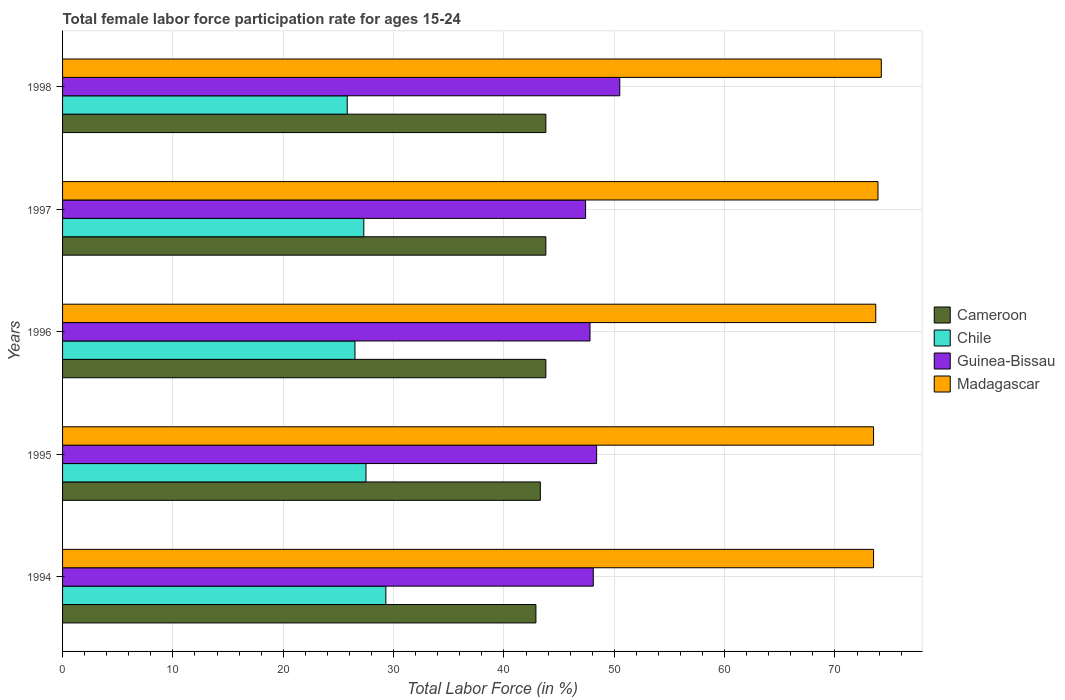How many different coloured bars are there?
Your response must be concise. 4. How many groups of bars are there?
Offer a terse response. 5. In how many cases, is the number of bars for a given year not equal to the number of legend labels?
Your answer should be compact. 0. What is the female labor force participation rate in Madagascar in 1998?
Your answer should be compact. 74.2. Across all years, what is the maximum female labor force participation rate in Guinea-Bissau?
Your answer should be compact. 50.5. Across all years, what is the minimum female labor force participation rate in Cameroon?
Your answer should be compact. 42.9. In which year was the female labor force participation rate in Chile maximum?
Give a very brief answer. 1994. What is the total female labor force participation rate in Chile in the graph?
Keep it short and to the point. 136.4. What is the difference between the female labor force participation rate in Madagascar in 1995 and that in 1997?
Make the answer very short. -0.4. What is the difference between the female labor force participation rate in Chile in 1995 and the female labor force participation rate in Guinea-Bissau in 1997?
Provide a succinct answer. -19.9. What is the average female labor force participation rate in Madagascar per year?
Give a very brief answer. 73.76. In how many years, is the female labor force participation rate in Guinea-Bissau greater than 68 %?
Your answer should be compact. 0. What is the ratio of the female labor force participation rate in Madagascar in 1996 to that in 1997?
Your answer should be very brief. 1. Is the female labor force participation rate in Guinea-Bissau in 1996 less than that in 1998?
Keep it short and to the point. Yes. What is the difference between the highest and the second highest female labor force participation rate in Madagascar?
Give a very brief answer. 0.3. What is the difference between the highest and the lowest female labor force participation rate in Guinea-Bissau?
Give a very brief answer. 3.1. Is the sum of the female labor force participation rate in Guinea-Bissau in 1994 and 1998 greater than the maximum female labor force participation rate in Madagascar across all years?
Keep it short and to the point. Yes. Is it the case that in every year, the sum of the female labor force participation rate in Madagascar and female labor force participation rate in Guinea-Bissau is greater than the female labor force participation rate in Chile?
Your response must be concise. Yes. How many years are there in the graph?
Offer a terse response. 5. What is the difference between two consecutive major ticks on the X-axis?
Your response must be concise. 10. Where does the legend appear in the graph?
Make the answer very short. Center right. How many legend labels are there?
Your answer should be compact. 4. What is the title of the graph?
Give a very brief answer. Total female labor force participation rate for ages 15-24. Does "New Zealand" appear as one of the legend labels in the graph?
Your answer should be compact. No. What is the Total Labor Force (in %) of Cameroon in 1994?
Provide a succinct answer. 42.9. What is the Total Labor Force (in %) of Chile in 1994?
Your response must be concise. 29.3. What is the Total Labor Force (in %) of Guinea-Bissau in 1994?
Your answer should be very brief. 48.1. What is the Total Labor Force (in %) of Madagascar in 1994?
Your answer should be very brief. 73.5. What is the Total Labor Force (in %) in Cameroon in 1995?
Your answer should be compact. 43.3. What is the Total Labor Force (in %) of Chile in 1995?
Offer a terse response. 27.5. What is the Total Labor Force (in %) in Guinea-Bissau in 1995?
Provide a short and direct response. 48.4. What is the Total Labor Force (in %) of Madagascar in 1995?
Make the answer very short. 73.5. What is the Total Labor Force (in %) in Cameroon in 1996?
Provide a succinct answer. 43.8. What is the Total Labor Force (in %) in Chile in 1996?
Provide a short and direct response. 26.5. What is the Total Labor Force (in %) in Guinea-Bissau in 1996?
Offer a very short reply. 47.8. What is the Total Labor Force (in %) in Madagascar in 1996?
Make the answer very short. 73.7. What is the Total Labor Force (in %) of Cameroon in 1997?
Ensure brevity in your answer.  43.8. What is the Total Labor Force (in %) in Chile in 1997?
Provide a succinct answer. 27.3. What is the Total Labor Force (in %) of Guinea-Bissau in 1997?
Your response must be concise. 47.4. What is the Total Labor Force (in %) of Madagascar in 1997?
Make the answer very short. 73.9. What is the Total Labor Force (in %) in Cameroon in 1998?
Your answer should be compact. 43.8. What is the Total Labor Force (in %) in Chile in 1998?
Ensure brevity in your answer.  25.8. What is the Total Labor Force (in %) of Guinea-Bissau in 1998?
Keep it short and to the point. 50.5. What is the Total Labor Force (in %) of Madagascar in 1998?
Your answer should be very brief. 74.2. Across all years, what is the maximum Total Labor Force (in %) of Cameroon?
Offer a very short reply. 43.8. Across all years, what is the maximum Total Labor Force (in %) of Chile?
Your answer should be compact. 29.3. Across all years, what is the maximum Total Labor Force (in %) of Guinea-Bissau?
Offer a very short reply. 50.5. Across all years, what is the maximum Total Labor Force (in %) of Madagascar?
Your answer should be compact. 74.2. Across all years, what is the minimum Total Labor Force (in %) in Cameroon?
Your answer should be compact. 42.9. Across all years, what is the minimum Total Labor Force (in %) of Chile?
Offer a terse response. 25.8. Across all years, what is the minimum Total Labor Force (in %) in Guinea-Bissau?
Provide a short and direct response. 47.4. Across all years, what is the minimum Total Labor Force (in %) of Madagascar?
Your answer should be very brief. 73.5. What is the total Total Labor Force (in %) of Cameroon in the graph?
Offer a very short reply. 217.6. What is the total Total Labor Force (in %) of Chile in the graph?
Offer a terse response. 136.4. What is the total Total Labor Force (in %) in Guinea-Bissau in the graph?
Your response must be concise. 242.2. What is the total Total Labor Force (in %) of Madagascar in the graph?
Keep it short and to the point. 368.8. What is the difference between the Total Labor Force (in %) in Cameroon in 1994 and that in 1995?
Make the answer very short. -0.4. What is the difference between the Total Labor Force (in %) in Chile in 1994 and that in 1995?
Offer a very short reply. 1.8. What is the difference between the Total Labor Force (in %) of Madagascar in 1994 and that in 1996?
Your answer should be very brief. -0.2. What is the difference between the Total Labor Force (in %) of Cameroon in 1994 and that in 1997?
Provide a short and direct response. -0.9. What is the difference between the Total Labor Force (in %) of Chile in 1994 and that in 1997?
Offer a very short reply. 2. What is the difference between the Total Labor Force (in %) in Guinea-Bissau in 1994 and that in 1997?
Your answer should be very brief. 0.7. What is the difference between the Total Labor Force (in %) in Cameroon in 1994 and that in 1998?
Offer a very short reply. -0.9. What is the difference between the Total Labor Force (in %) in Chile in 1994 and that in 1998?
Offer a very short reply. 3.5. What is the difference between the Total Labor Force (in %) in Guinea-Bissau in 1994 and that in 1998?
Your answer should be very brief. -2.4. What is the difference between the Total Labor Force (in %) of Chile in 1995 and that in 1996?
Your response must be concise. 1. What is the difference between the Total Labor Force (in %) in Madagascar in 1995 and that in 1996?
Your answer should be compact. -0.2. What is the difference between the Total Labor Force (in %) in Cameroon in 1995 and that in 1997?
Provide a succinct answer. -0.5. What is the difference between the Total Labor Force (in %) of Chile in 1995 and that in 1997?
Provide a succinct answer. 0.2. What is the difference between the Total Labor Force (in %) in Madagascar in 1995 and that in 1997?
Keep it short and to the point. -0.4. What is the difference between the Total Labor Force (in %) of Guinea-Bissau in 1995 and that in 1998?
Your response must be concise. -2.1. What is the difference between the Total Labor Force (in %) of Cameroon in 1996 and that in 1997?
Offer a terse response. 0. What is the difference between the Total Labor Force (in %) of Guinea-Bissau in 1996 and that in 1997?
Offer a terse response. 0.4. What is the difference between the Total Labor Force (in %) in Madagascar in 1996 and that in 1997?
Offer a terse response. -0.2. What is the difference between the Total Labor Force (in %) of Madagascar in 1997 and that in 1998?
Offer a terse response. -0.3. What is the difference between the Total Labor Force (in %) of Cameroon in 1994 and the Total Labor Force (in %) of Madagascar in 1995?
Give a very brief answer. -30.6. What is the difference between the Total Labor Force (in %) in Chile in 1994 and the Total Labor Force (in %) in Guinea-Bissau in 1995?
Give a very brief answer. -19.1. What is the difference between the Total Labor Force (in %) in Chile in 1994 and the Total Labor Force (in %) in Madagascar in 1995?
Your answer should be compact. -44.2. What is the difference between the Total Labor Force (in %) of Guinea-Bissau in 1994 and the Total Labor Force (in %) of Madagascar in 1995?
Offer a very short reply. -25.4. What is the difference between the Total Labor Force (in %) of Cameroon in 1994 and the Total Labor Force (in %) of Chile in 1996?
Make the answer very short. 16.4. What is the difference between the Total Labor Force (in %) in Cameroon in 1994 and the Total Labor Force (in %) in Guinea-Bissau in 1996?
Your response must be concise. -4.9. What is the difference between the Total Labor Force (in %) of Cameroon in 1994 and the Total Labor Force (in %) of Madagascar in 1996?
Offer a terse response. -30.8. What is the difference between the Total Labor Force (in %) in Chile in 1994 and the Total Labor Force (in %) in Guinea-Bissau in 1996?
Make the answer very short. -18.5. What is the difference between the Total Labor Force (in %) in Chile in 1994 and the Total Labor Force (in %) in Madagascar in 1996?
Provide a short and direct response. -44.4. What is the difference between the Total Labor Force (in %) in Guinea-Bissau in 1994 and the Total Labor Force (in %) in Madagascar in 1996?
Ensure brevity in your answer.  -25.6. What is the difference between the Total Labor Force (in %) in Cameroon in 1994 and the Total Labor Force (in %) in Chile in 1997?
Give a very brief answer. 15.6. What is the difference between the Total Labor Force (in %) in Cameroon in 1994 and the Total Labor Force (in %) in Madagascar in 1997?
Give a very brief answer. -31. What is the difference between the Total Labor Force (in %) of Chile in 1994 and the Total Labor Force (in %) of Guinea-Bissau in 1997?
Ensure brevity in your answer.  -18.1. What is the difference between the Total Labor Force (in %) in Chile in 1994 and the Total Labor Force (in %) in Madagascar in 1997?
Give a very brief answer. -44.6. What is the difference between the Total Labor Force (in %) in Guinea-Bissau in 1994 and the Total Labor Force (in %) in Madagascar in 1997?
Ensure brevity in your answer.  -25.8. What is the difference between the Total Labor Force (in %) in Cameroon in 1994 and the Total Labor Force (in %) in Chile in 1998?
Provide a succinct answer. 17.1. What is the difference between the Total Labor Force (in %) of Cameroon in 1994 and the Total Labor Force (in %) of Madagascar in 1998?
Provide a succinct answer. -31.3. What is the difference between the Total Labor Force (in %) of Chile in 1994 and the Total Labor Force (in %) of Guinea-Bissau in 1998?
Keep it short and to the point. -21.2. What is the difference between the Total Labor Force (in %) of Chile in 1994 and the Total Labor Force (in %) of Madagascar in 1998?
Provide a short and direct response. -44.9. What is the difference between the Total Labor Force (in %) in Guinea-Bissau in 1994 and the Total Labor Force (in %) in Madagascar in 1998?
Your answer should be very brief. -26.1. What is the difference between the Total Labor Force (in %) in Cameroon in 1995 and the Total Labor Force (in %) in Chile in 1996?
Ensure brevity in your answer.  16.8. What is the difference between the Total Labor Force (in %) of Cameroon in 1995 and the Total Labor Force (in %) of Guinea-Bissau in 1996?
Ensure brevity in your answer.  -4.5. What is the difference between the Total Labor Force (in %) in Cameroon in 1995 and the Total Labor Force (in %) in Madagascar in 1996?
Offer a terse response. -30.4. What is the difference between the Total Labor Force (in %) in Chile in 1995 and the Total Labor Force (in %) in Guinea-Bissau in 1996?
Offer a very short reply. -20.3. What is the difference between the Total Labor Force (in %) of Chile in 1995 and the Total Labor Force (in %) of Madagascar in 1996?
Give a very brief answer. -46.2. What is the difference between the Total Labor Force (in %) of Guinea-Bissau in 1995 and the Total Labor Force (in %) of Madagascar in 1996?
Your response must be concise. -25.3. What is the difference between the Total Labor Force (in %) of Cameroon in 1995 and the Total Labor Force (in %) of Chile in 1997?
Offer a very short reply. 16. What is the difference between the Total Labor Force (in %) of Cameroon in 1995 and the Total Labor Force (in %) of Guinea-Bissau in 1997?
Your answer should be very brief. -4.1. What is the difference between the Total Labor Force (in %) of Cameroon in 1995 and the Total Labor Force (in %) of Madagascar in 1997?
Keep it short and to the point. -30.6. What is the difference between the Total Labor Force (in %) of Chile in 1995 and the Total Labor Force (in %) of Guinea-Bissau in 1997?
Your response must be concise. -19.9. What is the difference between the Total Labor Force (in %) in Chile in 1995 and the Total Labor Force (in %) in Madagascar in 1997?
Provide a short and direct response. -46.4. What is the difference between the Total Labor Force (in %) of Guinea-Bissau in 1995 and the Total Labor Force (in %) of Madagascar in 1997?
Make the answer very short. -25.5. What is the difference between the Total Labor Force (in %) of Cameroon in 1995 and the Total Labor Force (in %) of Guinea-Bissau in 1998?
Your answer should be compact. -7.2. What is the difference between the Total Labor Force (in %) in Cameroon in 1995 and the Total Labor Force (in %) in Madagascar in 1998?
Provide a short and direct response. -30.9. What is the difference between the Total Labor Force (in %) in Chile in 1995 and the Total Labor Force (in %) in Madagascar in 1998?
Give a very brief answer. -46.7. What is the difference between the Total Labor Force (in %) of Guinea-Bissau in 1995 and the Total Labor Force (in %) of Madagascar in 1998?
Offer a terse response. -25.8. What is the difference between the Total Labor Force (in %) of Cameroon in 1996 and the Total Labor Force (in %) of Madagascar in 1997?
Make the answer very short. -30.1. What is the difference between the Total Labor Force (in %) in Chile in 1996 and the Total Labor Force (in %) in Guinea-Bissau in 1997?
Offer a very short reply. -20.9. What is the difference between the Total Labor Force (in %) of Chile in 1996 and the Total Labor Force (in %) of Madagascar in 1997?
Give a very brief answer. -47.4. What is the difference between the Total Labor Force (in %) in Guinea-Bissau in 1996 and the Total Labor Force (in %) in Madagascar in 1997?
Provide a succinct answer. -26.1. What is the difference between the Total Labor Force (in %) of Cameroon in 1996 and the Total Labor Force (in %) of Madagascar in 1998?
Make the answer very short. -30.4. What is the difference between the Total Labor Force (in %) of Chile in 1996 and the Total Labor Force (in %) of Guinea-Bissau in 1998?
Give a very brief answer. -24. What is the difference between the Total Labor Force (in %) of Chile in 1996 and the Total Labor Force (in %) of Madagascar in 1998?
Provide a succinct answer. -47.7. What is the difference between the Total Labor Force (in %) of Guinea-Bissau in 1996 and the Total Labor Force (in %) of Madagascar in 1998?
Provide a succinct answer. -26.4. What is the difference between the Total Labor Force (in %) of Cameroon in 1997 and the Total Labor Force (in %) of Chile in 1998?
Offer a terse response. 18. What is the difference between the Total Labor Force (in %) in Cameroon in 1997 and the Total Labor Force (in %) in Madagascar in 1998?
Ensure brevity in your answer.  -30.4. What is the difference between the Total Labor Force (in %) of Chile in 1997 and the Total Labor Force (in %) of Guinea-Bissau in 1998?
Provide a short and direct response. -23.2. What is the difference between the Total Labor Force (in %) of Chile in 1997 and the Total Labor Force (in %) of Madagascar in 1998?
Provide a succinct answer. -46.9. What is the difference between the Total Labor Force (in %) in Guinea-Bissau in 1997 and the Total Labor Force (in %) in Madagascar in 1998?
Offer a terse response. -26.8. What is the average Total Labor Force (in %) in Cameroon per year?
Keep it short and to the point. 43.52. What is the average Total Labor Force (in %) in Chile per year?
Keep it short and to the point. 27.28. What is the average Total Labor Force (in %) of Guinea-Bissau per year?
Offer a very short reply. 48.44. What is the average Total Labor Force (in %) of Madagascar per year?
Give a very brief answer. 73.76. In the year 1994, what is the difference between the Total Labor Force (in %) in Cameroon and Total Labor Force (in %) in Guinea-Bissau?
Keep it short and to the point. -5.2. In the year 1994, what is the difference between the Total Labor Force (in %) in Cameroon and Total Labor Force (in %) in Madagascar?
Your response must be concise. -30.6. In the year 1994, what is the difference between the Total Labor Force (in %) in Chile and Total Labor Force (in %) in Guinea-Bissau?
Make the answer very short. -18.8. In the year 1994, what is the difference between the Total Labor Force (in %) of Chile and Total Labor Force (in %) of Madagascar?
Ensure brevity in your answer.  -44.2. In the year 1994, what is the difference between the Total Labor Force (in %) of Guinea-Bissau and Total Labor Force (in %) of Madagascar?
Provide a short and direct response. -25.4. In the year 1995, what is the difference between the Total Labor Force (in %) of Cameroon and Total Labor Force (in %) of Guinea-Bissau?
Provide a succinct answer. -5.1. In the year 1995, what is the difference between the Total Labor Force (in %) of Cameroon and Total Labor Force (in %) of Madagascar?
Offer a very short reply. -30.2. In the year 1995, what is the difference between the Total Labor Force (in %) in Chile and Total Labor Force (in %) in Guinea-Bissau?
Your response must be concise. -20.9. In the year 1995, what is the difference between the Total Labor Force (in %) of Chile and Total Labor Force (in %) of Madagascar?
Ensure brevity in your answer.  -46. In the year 1995, what is the difference between the Total Labor Force (in %) of Guinea-Bissau and Total Labor Force (in %) of Madagascar?
Offer a terse response. -25.1. In the year 1996, what is the difference between the Total Labor Force (in %) of Cameroon and Total Labor Force (in %) of Chile?
Provide a succinct answer. 17.3. In the year 1996, what is the difference between the Total Labor Force (in %) of Cameroon and Total Labor Force (in %) of Madagascar?
Make the answer very short. -29.9. In the year 1996, what is the difference between the Total Labor Force (in %) of Chile and Total Labor Force (in %) of Guinea-Bissau?
Provide a succinct answer. -21.3. In the year 1996, what is the difference between the Total Labor Force (in %) of Chile and Total Labor Force (in %) of Madagascar?
Provide a short and direct response. -47.2. In the year 1996, what is the difference between the Total Labor Force (in %) of Guinea-Bissau and Total Labor Force (in %) of Madagascar?
Provide a short and direct response. -25.9. In the year 1997, what is the difference between the Total Labor Force (in %) in Cameroon and Total Labor Force (in %) in Madagascar?
Keep it short and to the point. -30.1. In the year 1997, what is the difference between the Total Labor Force (in %) of Chile and Total Labor Force (in %) of Guinea-Bissau?
Offer a terse response. -20.1. In the year 1997, what is the difference between the Total Labor Force (in %) of Chile and Total Labor Force (in %) of Madagascar?
Your answer should be very brief. -46.6. In the year 1997, what is the difference between the Total Labor Force (in %) in Guinea-Bissau and Total Labor Force (in %) in Madagascar?
Your answer should be compact. -26.5. In the year 1998, what is the difference between the Total Labor Force (in %) of Cameroon and Total Labor Force (in %) of Chile?
Provide a succinct answer. 18. In the year 1998, what is the difference between the Total Labor Force (in %) in Cameroon and Total Labor Force (in %) in Guinea-Bissau?
Provide a succinct answer. -6.7. In the year 1998, what is the difference between the Total Labor Force (in %) of Cameroon and Total Labor Force (in %) of Madagascar?
Provide a short and direct response. -30.4. In the year 1998, what is the difference between the Total Labor Force (in %) of Chile and Total Labor Force (in %) of Guinea-Bissau?
Provide a succinct answer. -24.7. In the year 1998, what is the difference between the Total Labor Force (in %) of Chile and Total Labor Force (in %) of Madagascar?
Your answer should be very brief. -48.4. In the year 1998, what is the difference between the Total Labor Force (in %) of Guinea-Bissau and Total Labor Force (in %) of Madagascar?
Your response must be concise. -23.7. What is the ratio of the Total Labor Force (in %) in Cameroon in 1994 to that in 1995?
Make the answer very short. 0.99. What is the ratio of the Total Labor Force (in %) of Chile in 1994 to that in 1995?
Offer a very short reply. 1.07. What is the ratio of the Total Labor Force (in %) of Guinea-Bissau in 1994 to that in 1995?
Provide a short and direct response. 0.99. What is the ratio of the Total Labor Force (in %) in Cameroon in 1994 to that in 1996?
Your answer should be compact. 0.98. What is the ratio of the Total Labor Force (in %) of Chile in 1994 to that in 1996?
Offer a terse response. 1.11. What is the ratio of the Total Labor Force (in %) in Guinea-Bissau in 1994 to that in 1996?
Provide a short and direct response. 1.01. What is the ratio of the Total Labor Force (in %) of Madagascar in 1994 to that in 1996?
Your answer should be compact. 1. What is the ratio of the Total Labor Force (in %) in Cameroon in 1994 to that in 1997?
Ensure brevity in your answer.  0.98. What is the ratio of the Total Labor Force (in %) of Chile in 1994 to that in 1997?
Your answer should be compact. 1.07. What is the ratio of the Total Labor Force (in %) in Guinea-Bissau in 1994 to that in 1997?
Offer a terse response. 1.01. What is the ratio of the Total Labor Force (in %) of Cameroon in 1994 to that in 1998?
Give a very brief answer. 0.98. What is the ratio of the Total Labor Force (in %) in Chile in 1994 to that in 1998?
Your answer should be very brief. 1.14. What is the ratio of the Total Labor Force (in %) of Guinea-Bissau in 1994 to that in 1998?
Provide a succinct answer. 0.95. What is the ratio of the Total Labor Force (in %) of Madagascar in 1994 to that in 1998?
Keep it short and to the point. 0.99. What is the ratio of the Total Labor Force (in %) of Chile in 1995 to that in 1996?
Provide a succinct answer. 1.04. What is the ratio of the Total Labor Force (in %) in Guinea-Bissau in 1995 to that in 1996?
Your answer should be compact. 1.01. What is the ratio of the Total Labor Force (in %) of Madagascar in 1995 to that in 1996?
Your answer should be very brief. 1. What is the ratio of the Total Labor Force (in %) in Chile in 1995 to that in 1997?
Provide a succinct answer. 1.01. What is the ratio of the Total Labor Force (in %) in Guinea-Bissau in 1995 to that in 1997?
Make the answer very short. 1.02. What is the ratio of the Total Labor Force (in %) of Madagascar in 1995 to that in 1997?
Your answer should be very brief. 0.99. What is the ratio of the Total Labor Force (in %) in Chile in 1995 to that in 1998?
Offer a very short reply. 1.07. What is the ratio of the Total Labor Force (in %) of Guinea-Bissau in 1995 to that in 1998?
Provide a succinct answer. 0.96. What is the ratio of the Total Labor Force (in %) of Madagascar in 1995 to that in 1998?
Give a very brief answer. 0.99. What is the ratio of the Total Labor Force (in %) of Chile in 1996 to that in 1997?
Offer a very short reply. 0.97. What is the ratio of the Total Labor Force (in %) of Guinea-Bissau in 1996 to that in 1997?
Make the answer very short. 1.01. What is the ratio of the Total Labor Force (in %) in Chile in 1996 to that in 1998?
Your answer should be compact. 1.03. What is the ratio of the Total Labor Force (in %) in Guinea-Bissau in 1996 to that in 1998?
Your answer should be compact. 0.95. What is the ratio of the Total Labor Force (in %) of Cameroon in 1997 to that in 1998?
Keep it short and to the point. 1. What is the ratio of the Total Labor Force (in %) in Chile in 1997 to that in 1998?
Keep it short and to the point. 1.06. What is the ratio of the Total Labor Force (in %) of Guinea-Bissau in 1997 to that in 1998?
Your answer should be very brief. 0.94. What is the difference between the highest and the second highest Total Labor Force (in %) in Cameroon?
Provide a short and direct response. 0. What is the difference between the highest and the second highest Total Labor Force (in %) in Guinea-Bissau?
Ensure brevity in your answer.  2.1. What is the difference between the highest and the lowest Total Labor Force (in %) in Cameroon?
Keep it short and to the point. 0.9. What is the difference between the highest and the lowest Total Labor Force (in %) of Chile?
Your answer should be compact. 3.5. 